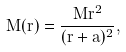Convert formula to latex. <formula><loc_0><loc_0><loc_500><loc_500>M ( r ) = \frac { M r ^ { 2 } } { ( r + a ) ^ { 2 } } ,</formula> 